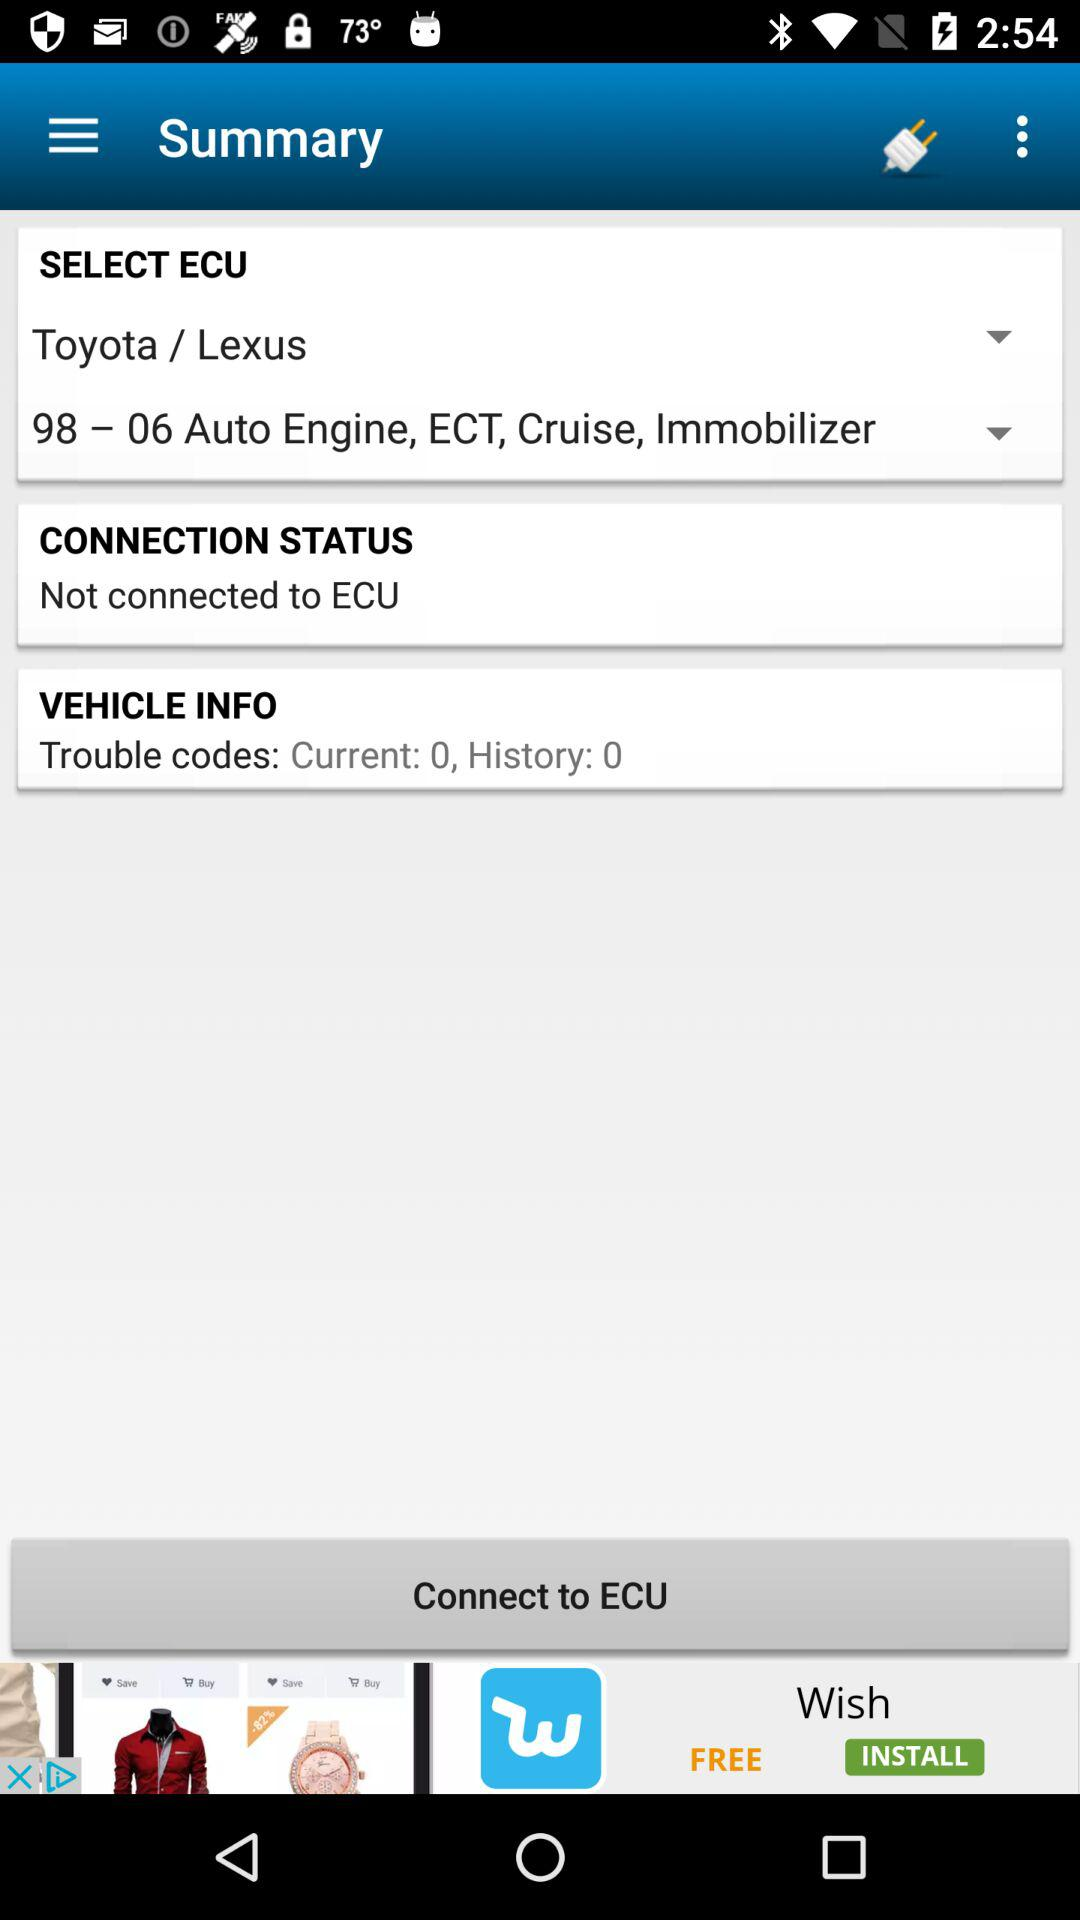What is the history count of Trouble codes in "VEHICLE INFO"? The count is 0. 